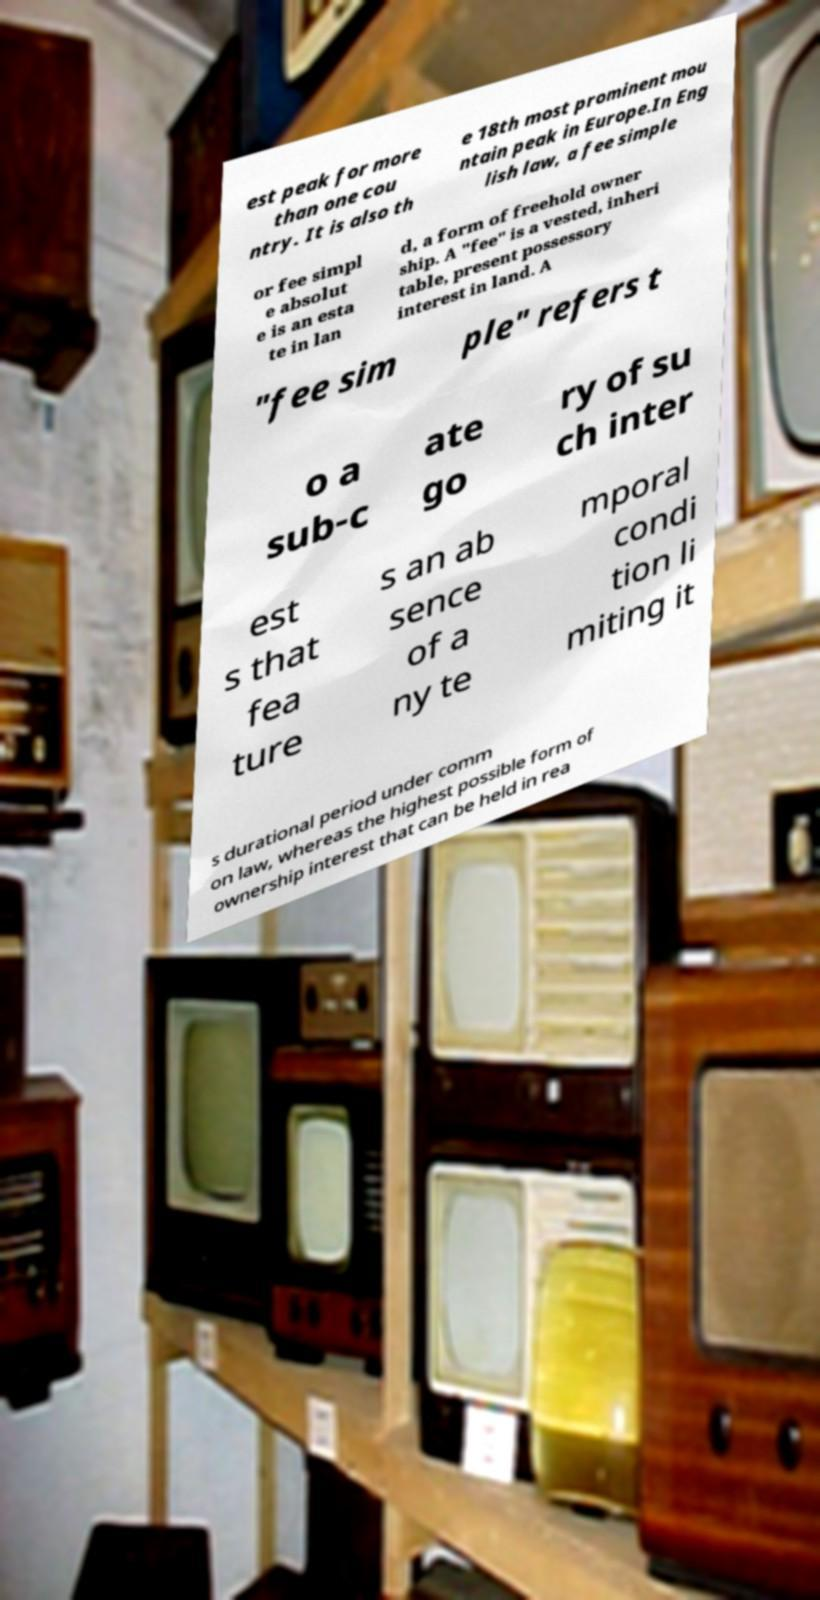I need the written content from this picture converted into text. Can you do that? est peak for more than one cou ntry. It is also th e 18th most prominent mou ntain peak in Europe.In Eng lish law, a fee simple or fee simpl e absolut e is an esta te in lan d, a form of freehold owner ship. A "fee" is a vested, inheri table, present possessory interest in land. A "fee sim ple" refers t o a sub-c ate go ry of su ch inter est s that fea ture s an ab sence of a ny te mporal condi tion li miting it s durational period under comm on law, whereas the highest possible form of ownership interest that can be held in rea 